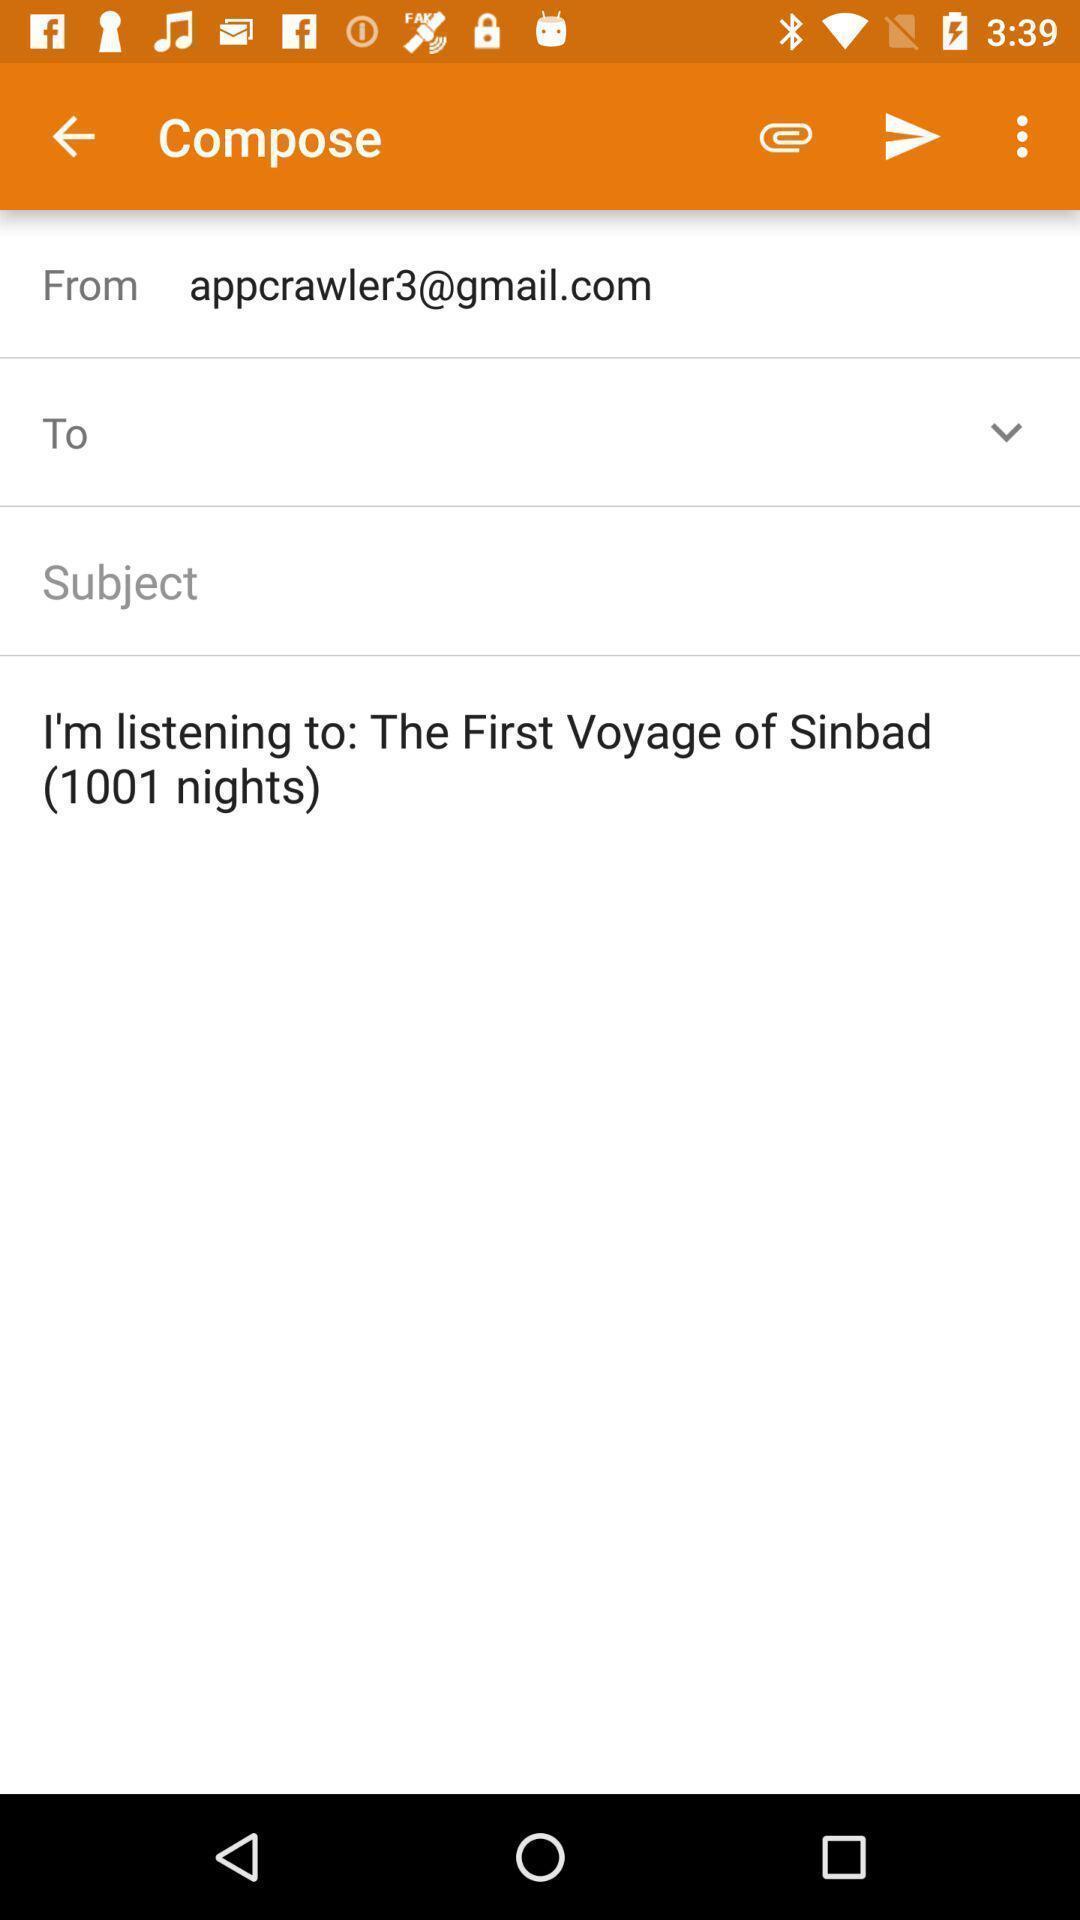Please provide a description for this image. Screen page displaying various options in social application. 